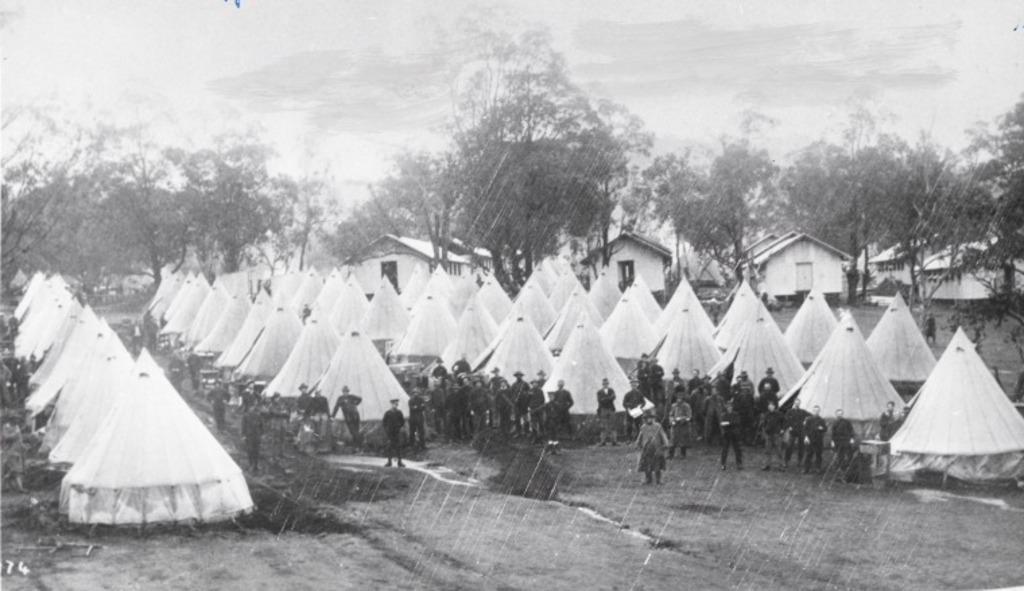What type of temporary shelters can be seen in the image? There are tents in the image. What are the people in the image doing? There is a group of people standing on the ground. What type of natural elements can be seen in the image? Trees are visible at the top of the image. What type of man-made structures can be seen in the image? Houses are visible at the top of the image. What type of hat is the thought wearing in the image? There is no hat or thought present in the image; it features tents, a group of people, trees, and houses. 